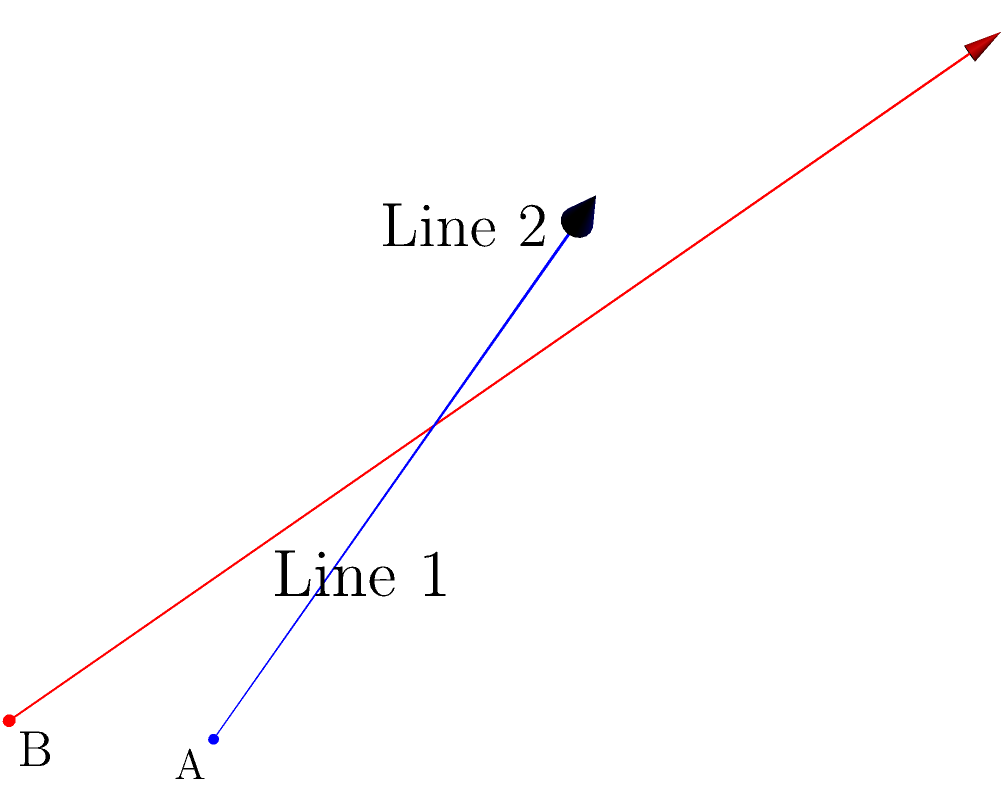In a three-dimensional space, two skew lines are given:

Line 1 passes through point $A(0,0,0)$ with direction vector $\vec{u} = (1,1,1)$
Line 2 passes through point $B(2,0,1)$ with direction vector $\vec{v} = (0,1,1)$

Find the shortest distance between these two skew lines. To find the shortest distance between two skew lines, we can follow these steps:

1) The vector perpendicular to both lines will give us the shortest distance. This vector can be found using the cross product of the direction vectors:
   $\vec{w} = \vec{u} \times \vec{v} = (1,1,1) \times (0,1,1) = (1,-1,1)$

2) Normalize $\vec{w}$:
   $\|\vec{w}\| = \sqrt{1^2 + (-1)^2 + 1^2} = \sqrt{3}$
   $\vec{w}_\text{unit} = \frac{\vec{w}}{\|\vec{w}\|} = (\frac{1}{\sqrt{3}}, -\frac{1}{\sqrt{3}}, \frac{1}{\sqrt{3}})$

3) The vector from A to B is:
   $\vec{AB} = B - A = (2,0,1) - (0,0,0) = (2,0,1)$

4) The shortest distance is the projection of $\vec{AB}$ onto $\vec{w}_\text{unit}$:
   $d = |\vec{AB} \cdot \vec{w}_\text{unit}|$
   $= |(2,0,1) \cdot (\frac{1}{\sqrt{3}}, -\frac{1}{\sqrt{3}}, \frac{1}{\sqrt{3}})|$
   $= |\frac{2}{\sqrt{3}} + 0 + \frac{1}{\sqrt{3}}|$
   $= |\frac{3}{\sqrt{3}}| = \sqrt{3}$

Therefore, the shortest distance between the two skew lines is $\sqrt{3}$ units.
Answer: $\sqrt{3}$ units 